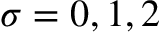Convert formula to latex. <formula><loc_0><loc_0><loc_500><loc_500>\sigma = 0 , 1 , 2</formula> 